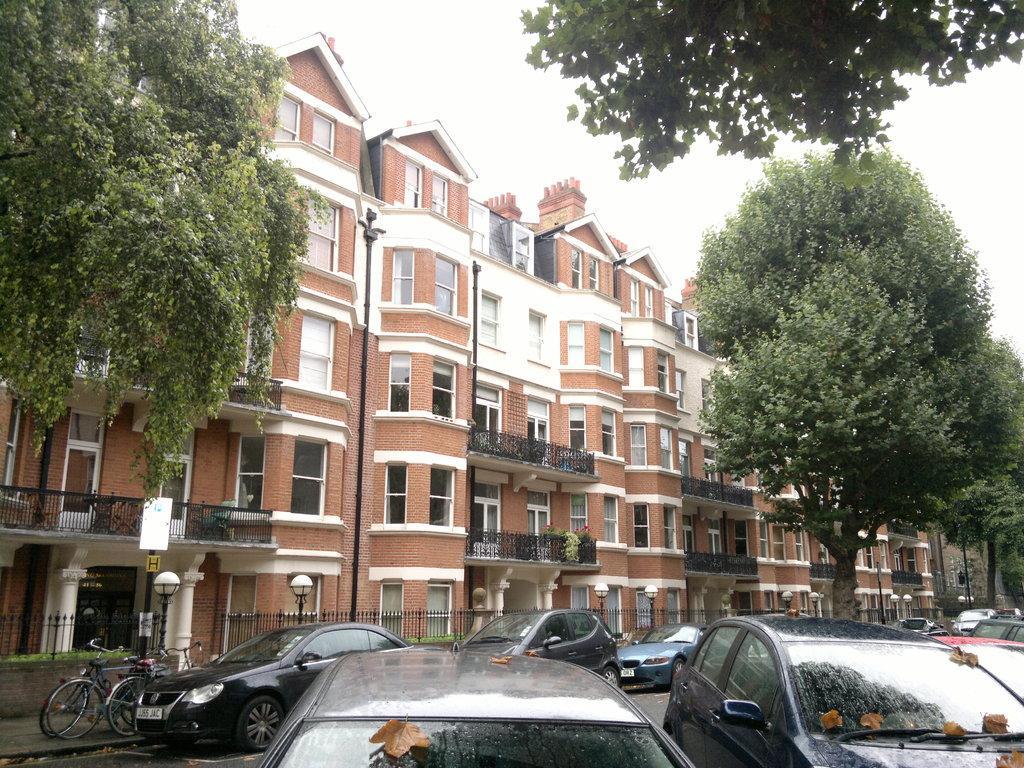Could you give a brief overview of what you see in this image? In this picture I can observe brown and white color buildings in the middle of the picture. In the bottom of the picture I can observe some cars parked in the parking lot. I can observe some trees in the picture. In the background there is sky. 